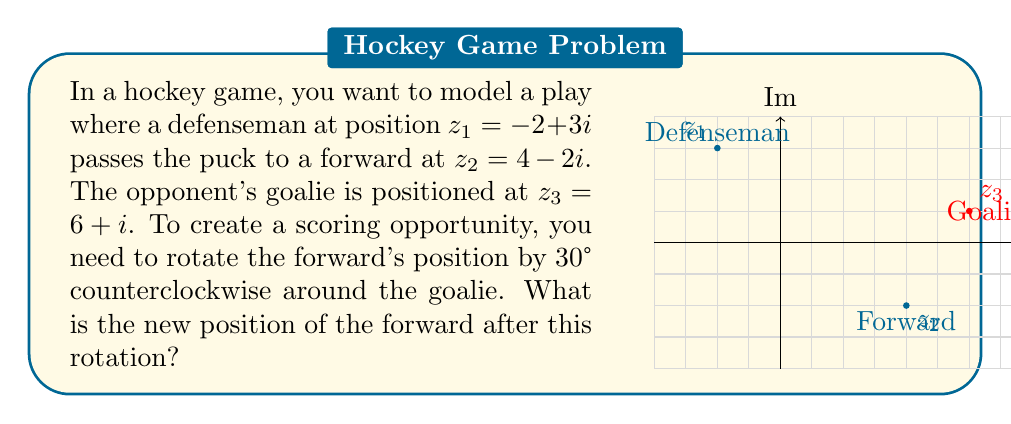Show me your answer to this math problem. Let's approach this step-by-step:

1) First, we need to express the rotation as a complex transformation. A rotation by θ counterclockwise around the origin is given by multiplication with $e^{iθ}$.

2) However, we're rotating around the goalie ($z_3$), not the origin. So we need to:
   a) Translate the plane so the goalie is at the origin
   b) Perform the rotation
   c) Translate back

3) The translation to move the goalie to the origin is achieved by subtracting $z_3$ from all points.

4) Our rotation angle is 30°, which is $\frac{\pi}{6}$ radians. So our rotation factor is $e^{i\frac{\pi}{6}}$.

5) Putting this all together, our transformation is:
   $$(z - z_3) \cdot e^{i\frac{\pi}{6}} + z_3$$

6) Let's apply this to $z_2$:
   $((4-2i) - (6+i)) \cdot e^{i\frac{\pi}{6}} + (6+i)$

7) Simplify the subtraction inside the parentheses:
   $(-2-3i) \cdot e^{i\frac{\pi}{6}} + (6+i)$

8) Now, $e^{i\frac{\pi}{6}} = \cos(\frac{\pi}{6}) + i\sin(\frac{\pi}{6}) = \frac{\sqrt{3}}{2} + \frac{1}{2}i$

9) Multiply:
   $(-2-3i)(\frac{\sqrt{3}}{2} + \frac{1}{2}i) + (6+i)$
   $= (-\sqrt{3} - \frac{3\sqrt{3}}{2}i) + (-1 + \frac{3}{2}i) + (6+i)$
   $= (-\sqrt{3} - \frac{3\sqrt{3}}{2}i - 1 + \frac{3}{2}i + 6 + i)$

10) Combining real and imaginary parts:
    $(5-\sqrt{3}) + (-\frac{3\sqrt{3}}{2} + \frac{5}{2})i$
Answer: $(5-\sqrt{3}) + (-\frac{3\sqrt{3}}{2} + \frac{5}{2})i$ 